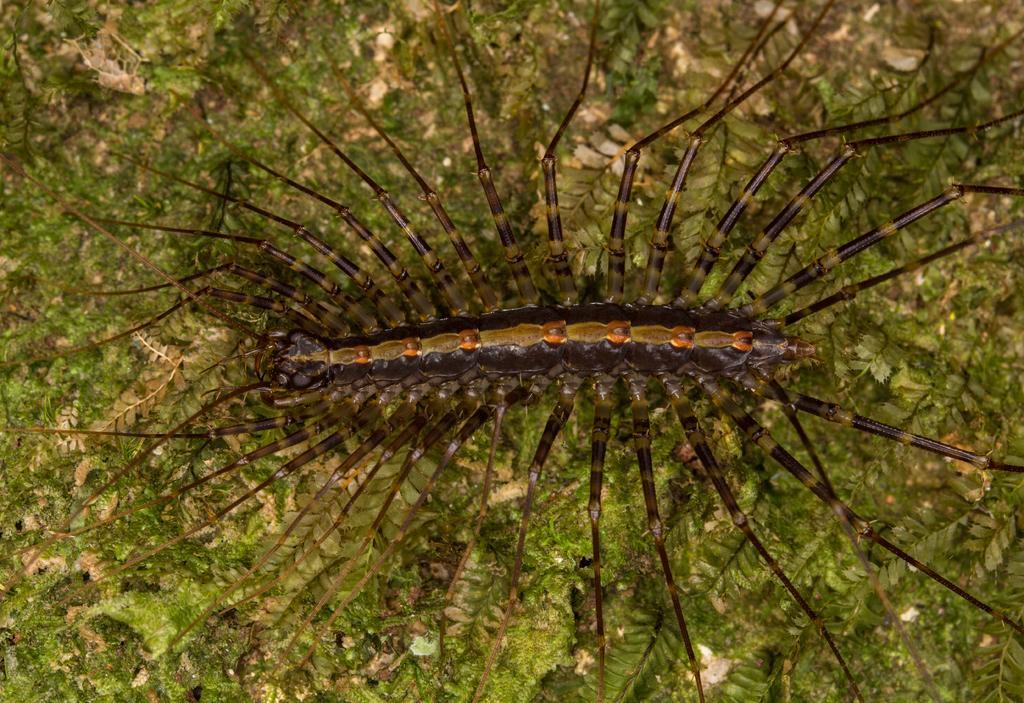Describe this image in one or two sentences. In this picture we can see an insect and in the background we can see leaves. 